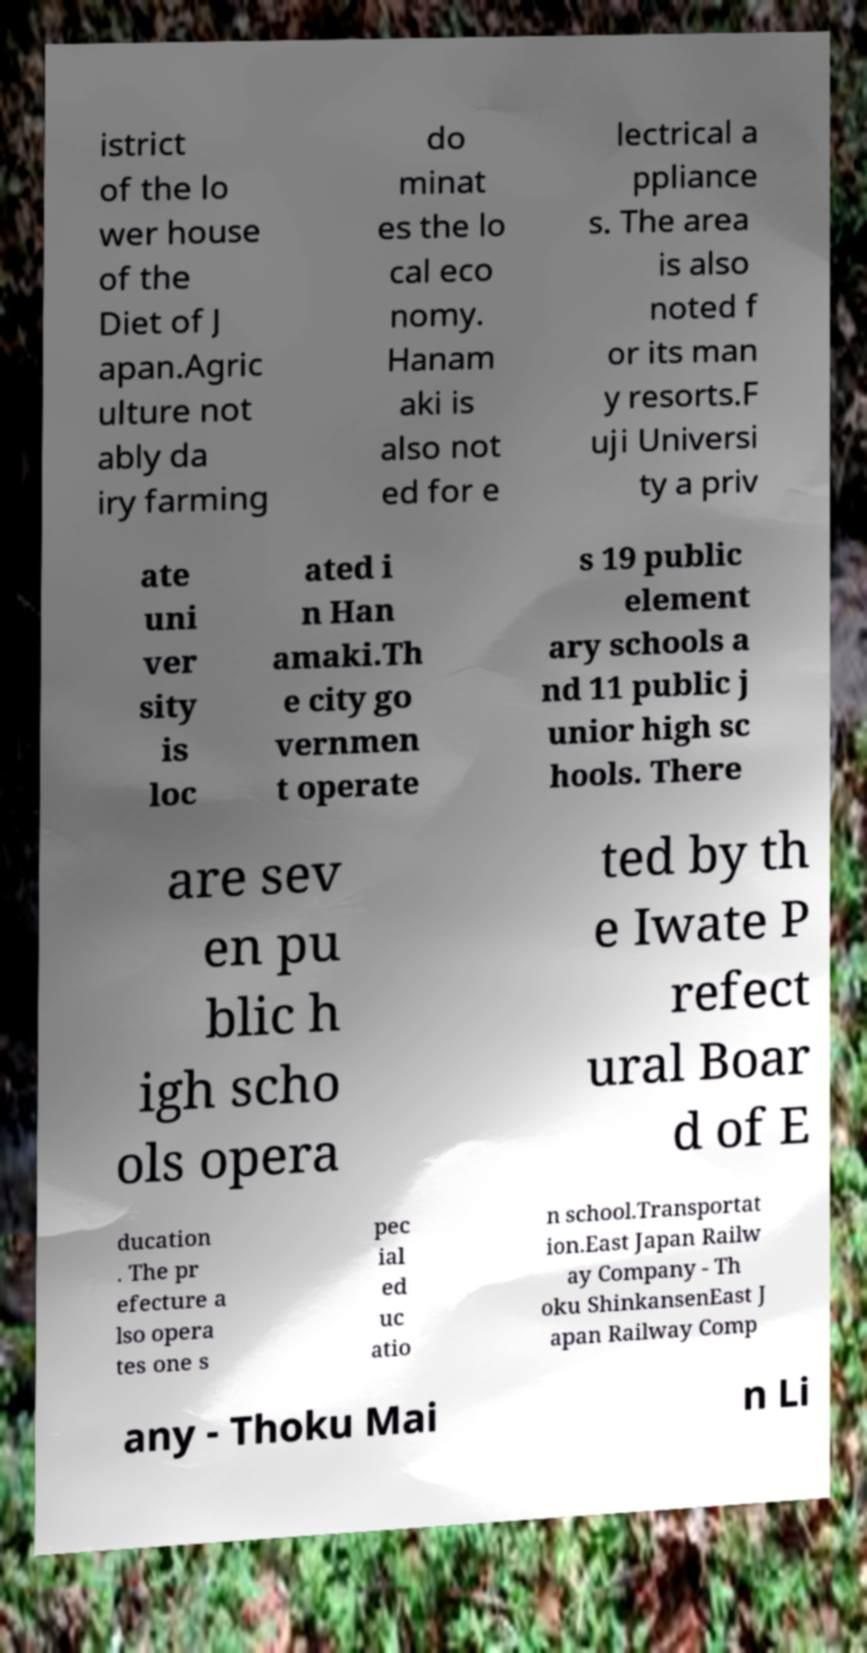I need the written content from this picture converted into text. Can you do that? istrict of the lo wer house of the Diet of J apan.Agric ulture not ably da iry farming do minat es the lo cal eco nomy. Hanam aki is also not ed for e lectrical a ppliance s. The area is also noted f or its man y resorts.F uji Universi ty a priv ate uni ver sity is loc ated i n Han amaki.Th e city go vernmen t operate s 19 public element ary schools a nd 11 public j unior high sc hools. There are sev en pu blic h igh scho ols opera ted by th e Iwate P refect ural Boar d of E ducation . The pr efecture a lso opera tes one s pec ial ed uc atio n school.Transportat ion.East Japan Railw ay Company - Th oku ShinkansenEast J apan Railway Comp any - Thoku Mai n Li 